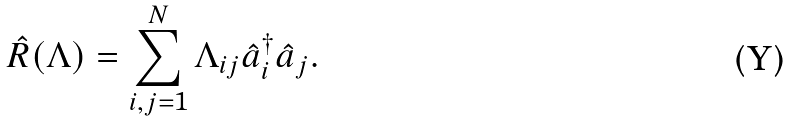<formula> <loc_0><loc_0><loc_500><loc_500>\hat { R } ( \Lambda ) = \sum _ { i , j = 1 } ^ { N } \Lambda _ { i j } \hat { a } _ { i } ^ { \dagger } \hat { a } _ { j } .</formula> 